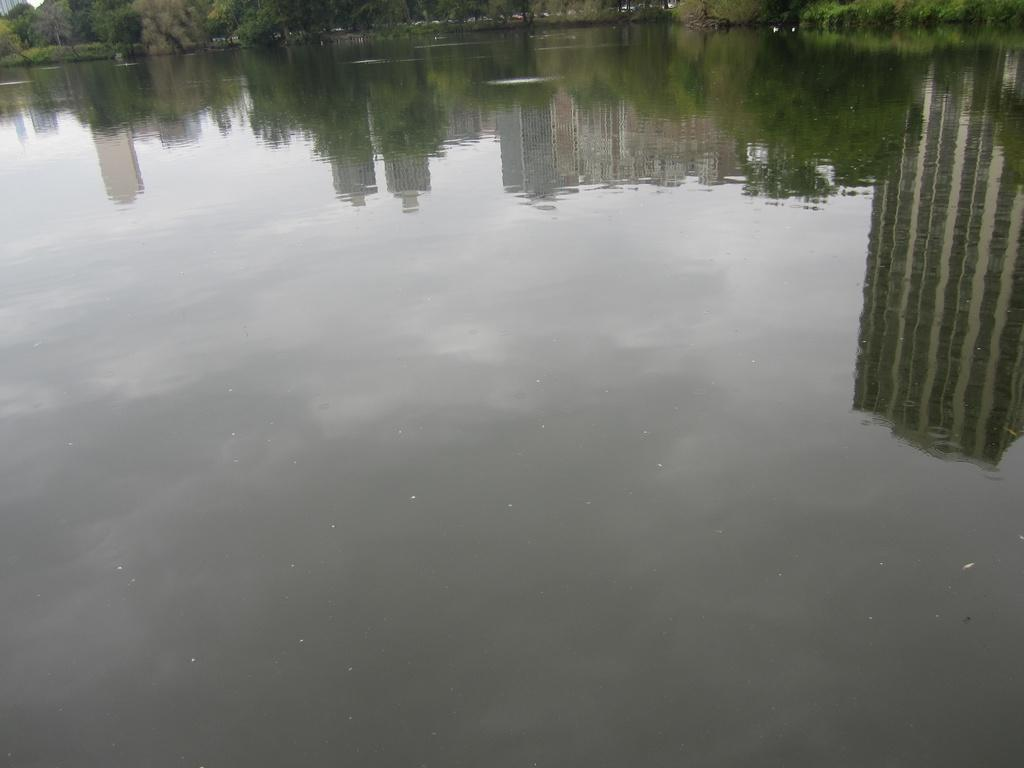What body of water is present in the image? There is a lake in the image. What can be seen in the reflection of the lake? The lake has a reflection of trees and buildings. How many receipts can be seen floating on the lake in the image? There are no receipts present in the image; it features a lake with reflections of trees and buildings. 